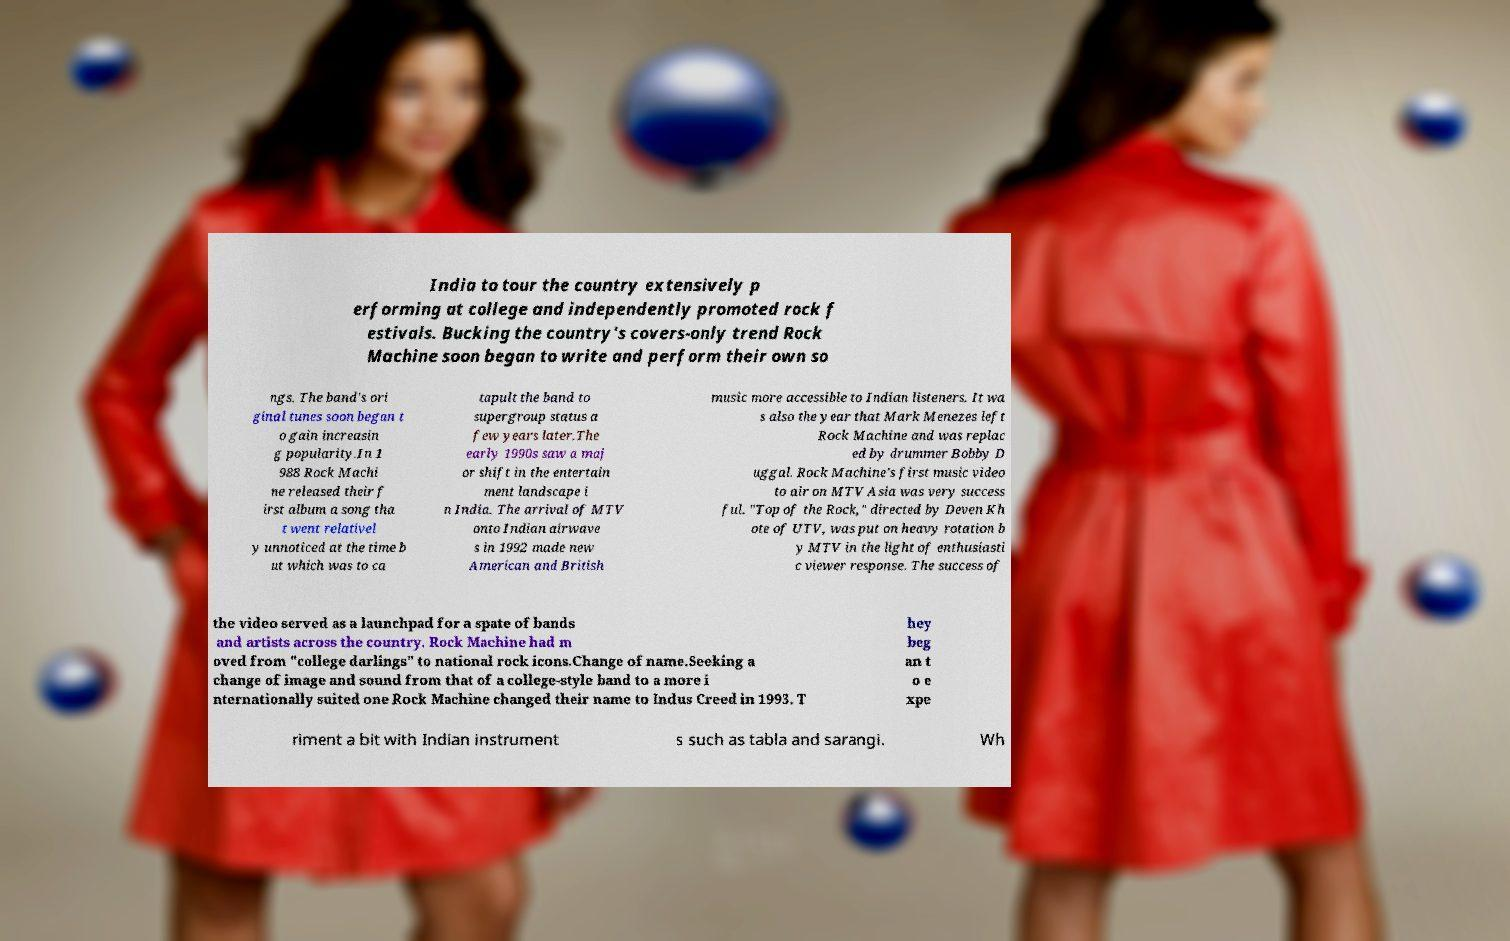Can you accurately transcribe the text from the provided image for me? India to tour the country extensively p erforming at college and independently promoted rock f estivals. Bucking the country's covers-only trend Rock Machine soon began to write and perform their own so ngs. The band's ori ginal tunes soon began t o gain increasin g popularity.In 1 988 Rock Machi ne released their f irst album a song tha t went relativel y unnoticed at the time b ut which was to ca tapult the band to supergroup status a few years later.The early 1990s saw a maj or shift in the entertain ment landscape i n India. The arrival of MTV onto Indian airwave s in 1992 made new American and British music more accessible to Indian listeners. It wa s also the year that Mark Menezes left Rock Machine and was replac ed by drummer Bobby D uggal. Rock Machine's first music video to air on MTV Asia was very success ful. "Top of the Rock," directed by Deven Kh ote of UTV, was put on heavy rotation b y MTV in the light of enthusiasti c viewer response. The success of the video served as a launchpad for a spate of bands and artists across the country. Rock Machine had m oved from "college darlings" to national rock icons.Change of name.Seeking a change of image and sound from that of a college-style band to a more i nternationally suited one Rock Machine changed their name to Indus Creed in 1993. T hey beg an t o e xpe riment a bit with Indian instrument s such as tabla and sarangi. Wh 